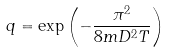<formula> <loc_0><loc_0><loc_500><loc_500>q = \exp \left ( - \frac { \pi ^ { 2 } } { 8 m D ^ { 2 } T } \right )</formula> 